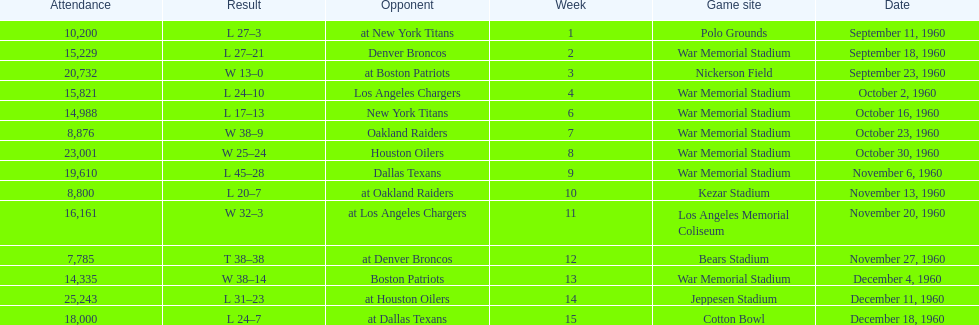What is the number of games with a maximum attendance of 10,000 people? 11. 